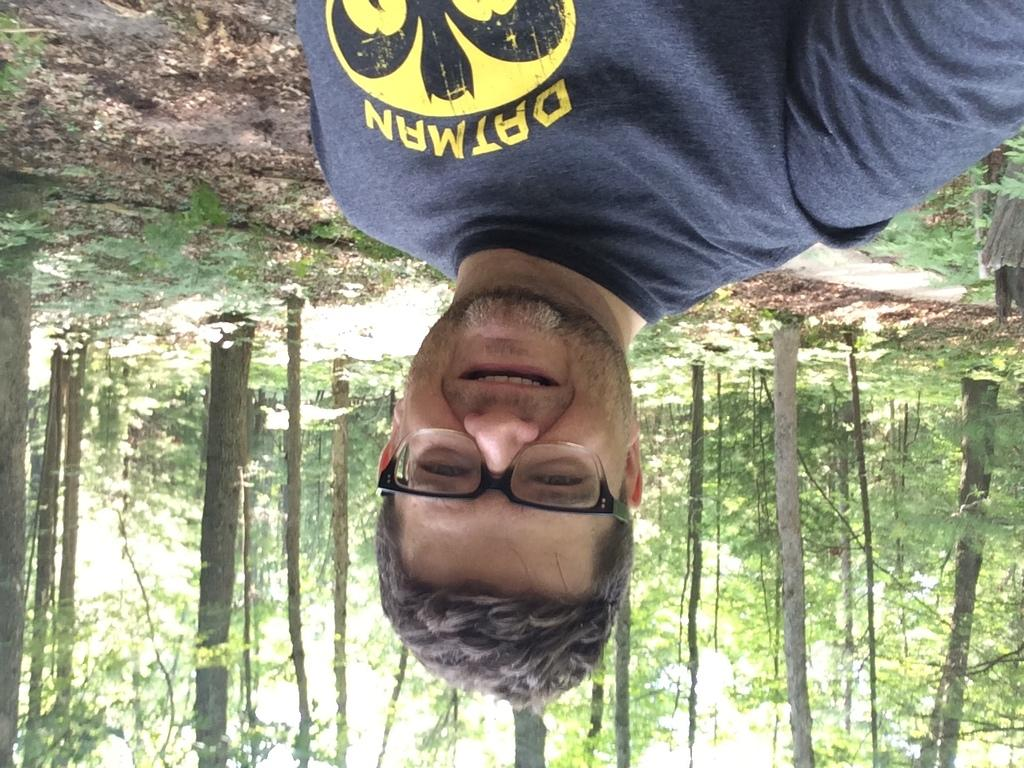Who is present in the image? There is a man in the image. What is the man doing in the image? The man is smiling in the image. What is the man wearing in the image? The man is wearing a t-shirt and spectacles in the image. What can be seen in the background of the image? There are trees in the background of the image. Can you see a river in the image? There is no river present in the image; only trees can be seen in the background. 